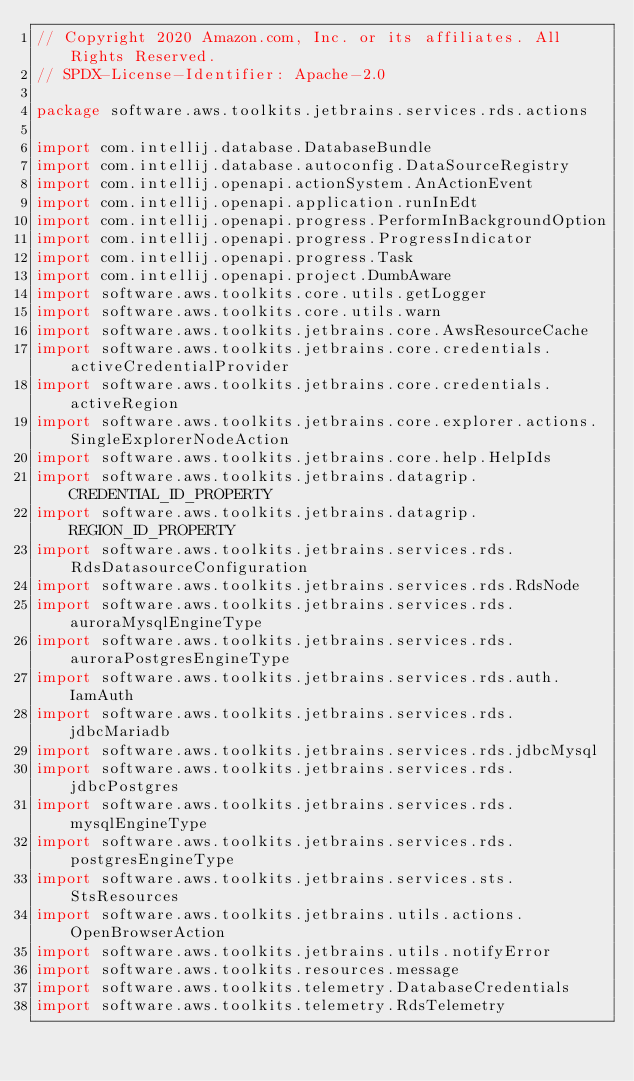Convert code to text. <code><loc_0><loc_0><loc_500><loc_500><_Kotlin_>// Copyright 2020 Amazon.com, Inc. or its affiliates. All Rights Reserved.
// SPDX-License-Identifier: Apache-2.0

package software.aws.toolkits.jetbrains.services.rds.actions

import com.intellij.database.DatabaseBundle
import com.intellij.database.autoconfig.DataSourceRegistry
import com.intellij.openapi.actionSystem.AnActionEvent
import com.intellij.openapi.application.runInEdt
import com.intellij.openapi.progress.PerformInBackgroundOption
import com.intellij.openapi.progress.ProgressIndicator
import com.intellij.openapi.progress.Task
import com.intellij.openapi.project.DumbAware
import software.aws.toolkits.core.utils.getLogger
import software.aws.toolkits.core.utils.warn
import software.aws.toolkits.jetbrains.core.AwsResourceCache
import software.aws.toolkits.jetbrains.core.credentials.activeCredentialProvider
import software.aws.toolkits.jetbrains.core.credentials.activeRegion
import software.aws.toolkits.jetbrains.core.explorer.actions.SingleExplorerNodeAction
import software.aws.toolkits.jetbrains.core.help.HelpIds
import software.aws.toolkits.jetbrains.datagrip.CREDENTIAL_ID_PROPERTY
import software.aws.toolkits.jetbrains.datagrip.REGION_ID_PROPERTY
import software.aws.toolkits.jetbrains.services.rds.RdsDatasourceConfiguration
import software.aws.toolkits.jetbrains.services.rds.RdsNode
import software.aws.toolkits.jetbrains.services.rds.auroraMysqlEngineType
import software.aws.toolkits.jetbrains.services.rds.auroraPostgresEngineType
import software.aws.toolkits.jetbrains.services.rds.auth.IamAuth
import software.aws.toolkits.jetbrains.services.rds.jdbcMariadb
import software.aws.toolkits.jetbrains.services.rds.jdbcMysql
import software.aws.toolkits.jetbrains.services.rds.jdbcPostgres
import software.aws.toolkits.jetbrains.services.rds.mysqlEngineType
import software.aws.toolkits.jetbrains.services.rds.postgresEngineType
import software.aws.toolkits.jetbrains.services.sts.StsResources
import software.aws.toolkits.jetbrains.utils.actions.OpenBrowserAction
import software.aws.toolkits.jetbrains.utils.notifyError
import software.aws.toolkits.resources.message
import software.aws.toolkits.telemetry.DatabaseCredentials
import software.aws.toolkits.telemetry.RdsTelemetry</code> 